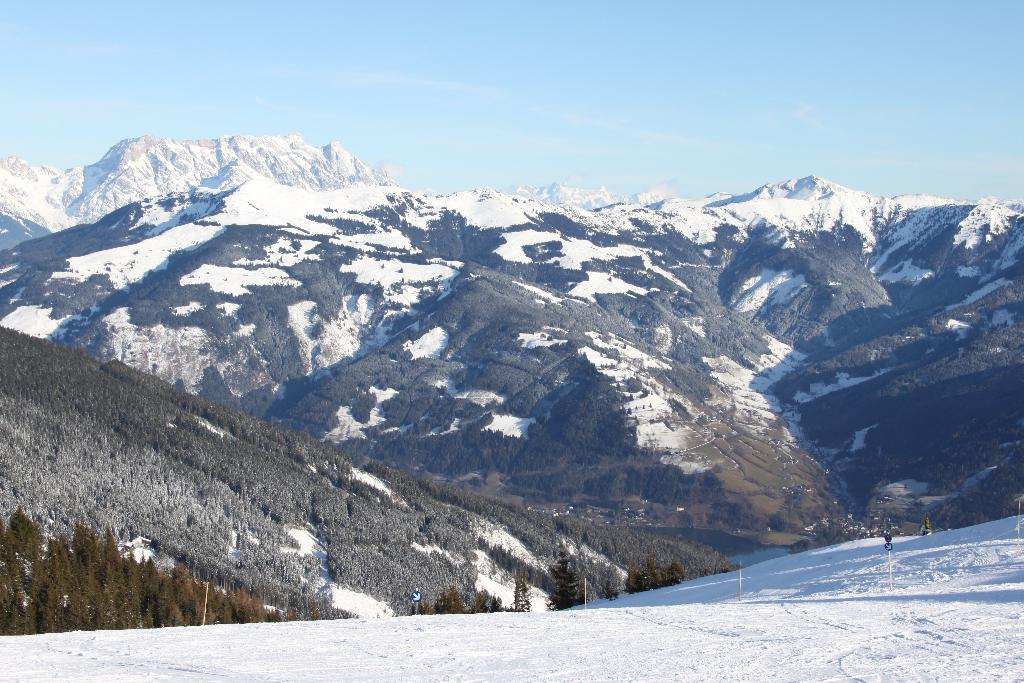What type of natural feature is visible in the image? There are mountains with snow in the image. What type of vegetation can be seen on the left side of the image? There are trees on the left side of the image. What is visible at the top of the image? The sky is visible at the top of the image. What type of produce is being harvested by the cats in the image? There are no cats or produce present in the image. What color is the cub's fur in the image? There is no cub present in the image. 